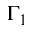Convert formula to latex. <formula><loc_0><loc_0><loc_500><loc_500>\Gamma _ { 1 }</formula> 